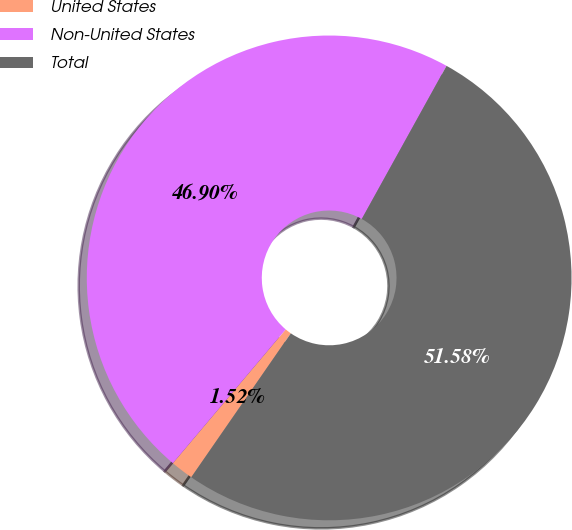Convert chart to OTSL. <chart><loc_0><loc_0><loc_500><loc_500><pie_chart><fcel>United States<fcel>Non-United States<fcel>Total<nl><fcel>1.52%<fcel>46.9%<fcel>51.59%<nl></chart> 